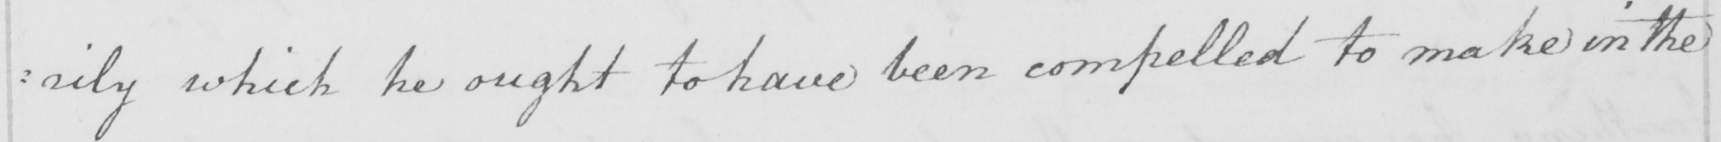Please provide the text content of this handwritten line. : rily which he ought to have been compelled to make in the 